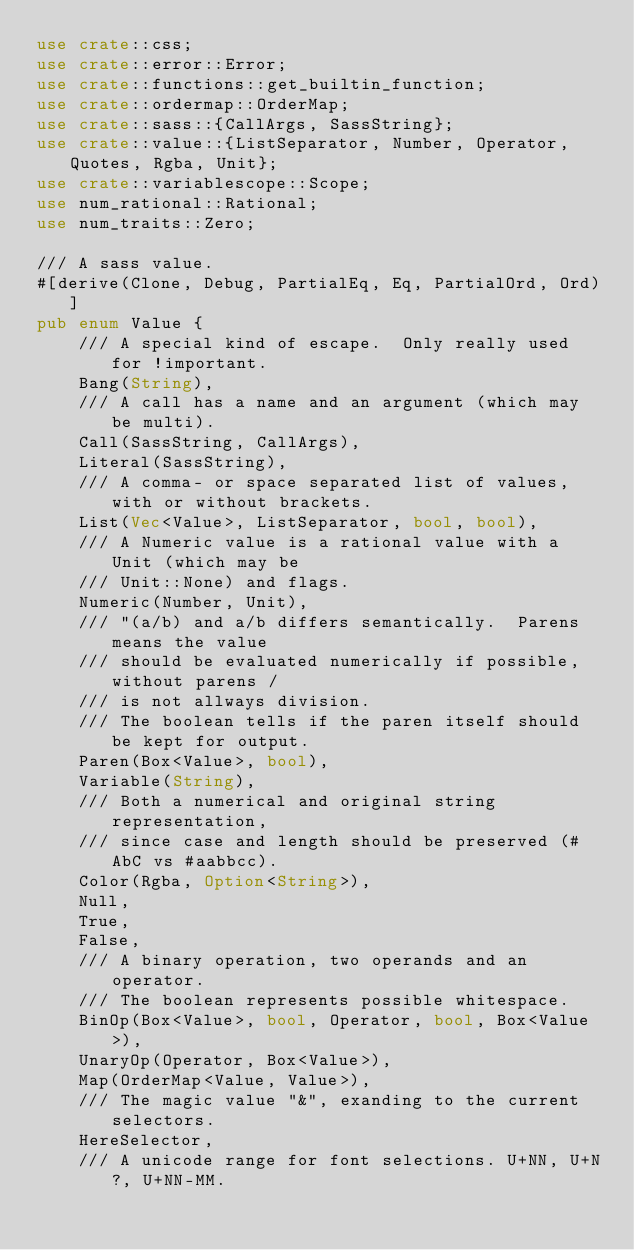Convert code to text. <code><loc_0><loc_0><loc_500><loc_500><_Rust_>use crate::css;
use crate::error::Error;
use crate::functions::get_builtin_function;
use crate::ordermap::OrderMap;
use crate::sass::{CallArgs, SassString};
use crate::value::{ListSeparator, Number, Operator, Quotes, Rgba, Unit};
use crate::variablescope::Scope;
use num_rational::Rational;
use num_traits::Zero;

/// A sass value.
#[derive(Clone, Debug, PartialEq, Eq, PartialOrd, Ord)]
pub enum Value {
    /// A special kind of escape.  Only really used for !important.
    Bang(String),
    /// A call has a name and an argument (which may be multi).
    Call(SassString, CallArgs),
    Literal(SassString),
    /// A comma- or space separated list of values, with or without brackets.
    List(Vec<Value>, ListSeparator, bool, bool),
    /// A Numeric value is a rational value with a Unit (which may be
    /// Unit::None) and flags.
    Numeric(Number, Unit),
    /// "(a/b) and a/b differs semantically.  Parens means the value
    /// should be evaluated numerically if possible, without parens /
    /// is not allways division.
    /// The boolean tells if the paren itself should be kept for output.
    Paren(Box<Value>, bool),
    Variable(String),
    /// Both a numerical and original string representation,
    /// since case and length should be preserved (#AbC vs #aabbcc).
    Color(Rgba, Option<String>),
    Null,
    True,
    False,
    /// A binary operation, two operands and an operator.
    /// The boolean represents possible whitespace.
    BinOp(Box<Value>, bool, Operator, bool, Box<Value>),
    UnaryOp(Operator, Box<Value>),
    Map(OrderMap<Value, Value>),
    /// The magic value "&", exanding to the current selectors.
    HereSelector,
    /// A unicode range for font selections. U+NN, U+N?, U+NN-MM.</code> 